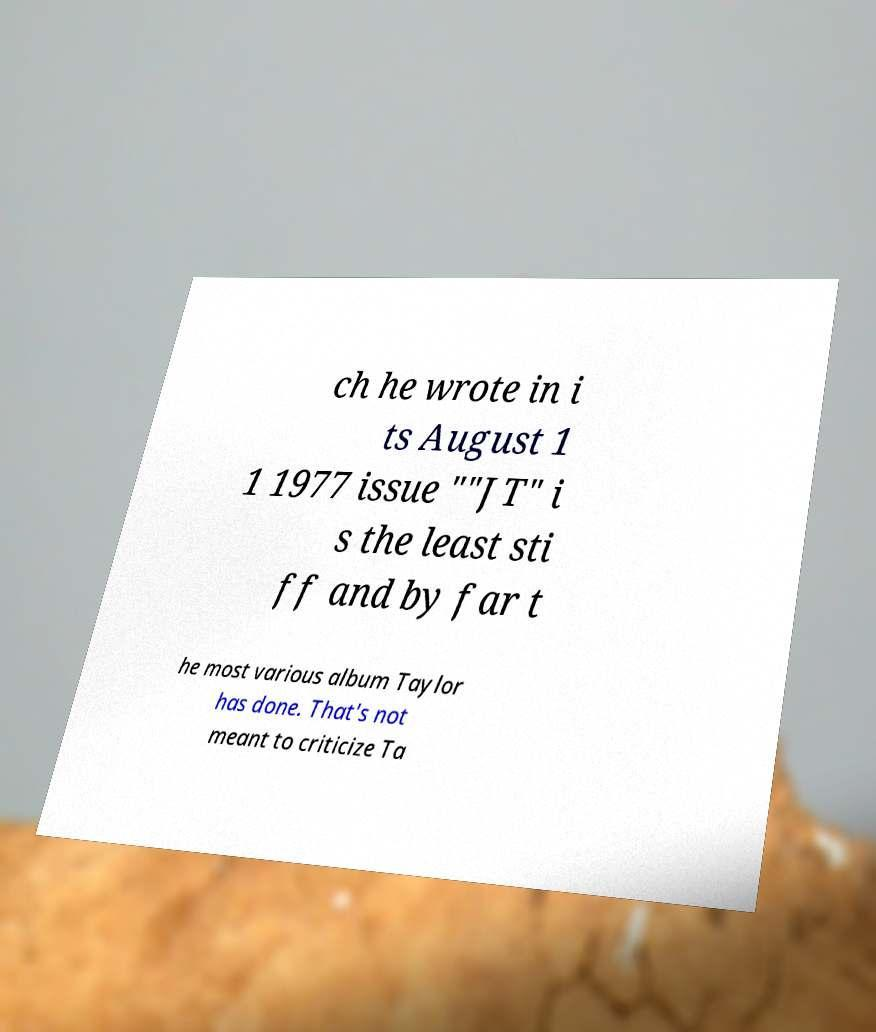There's text embedded in this image that I need extracted. Can you transcribe it verbatim? ch he wrote in i ts August 1 1 1977 issue ""JT" i s the least sti ff and by far t he most various album Taylor has done. That's not meant to criticize Ta 